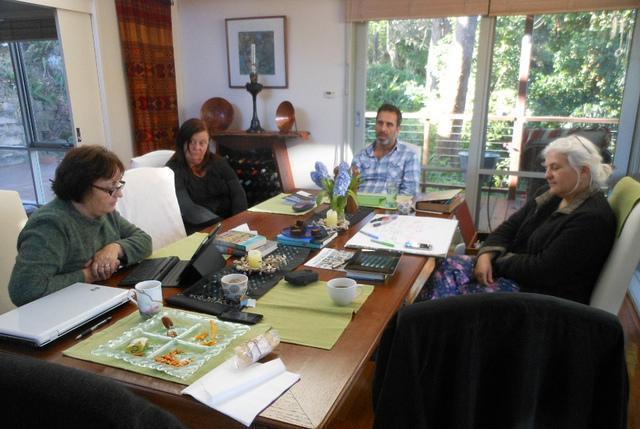What kind of gathering is this?
From the following four choices, select the correct answer to address the question.
Options: Business, religious, social, family. Business. 